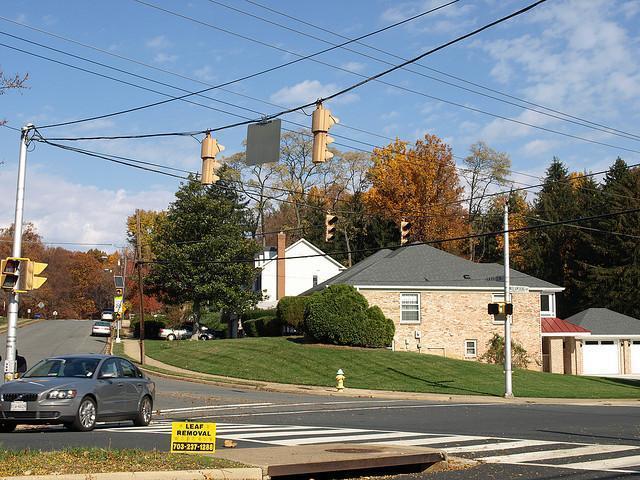How many cars are on the road?
Give a very brief answer. 1. How many real live dogs are in the photo?
Give a very brief answer. 0. 